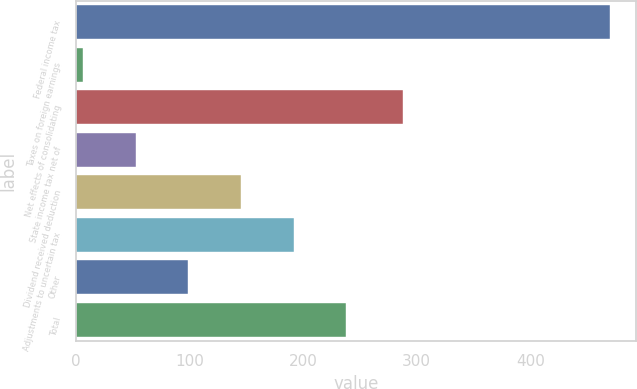Convert chart. <chart><loc_0><loc_0><loc_500><loc_500><bar_chart><fcel>Federal income tax<fcel>Taxes on foreign earnings<fcel>Net effects of consolidating<fcel>State income tax net of<fcel>Dividend received deduction<fcel>Adjustments to uncertain tax<fcel>Other<fcel>Total<nl><fcel>470<fcel>6<fcel>288<fcel>52.4<fcel>145.2<fcel>191.6<fcel>98.8<fcel>238<nl></chart> 